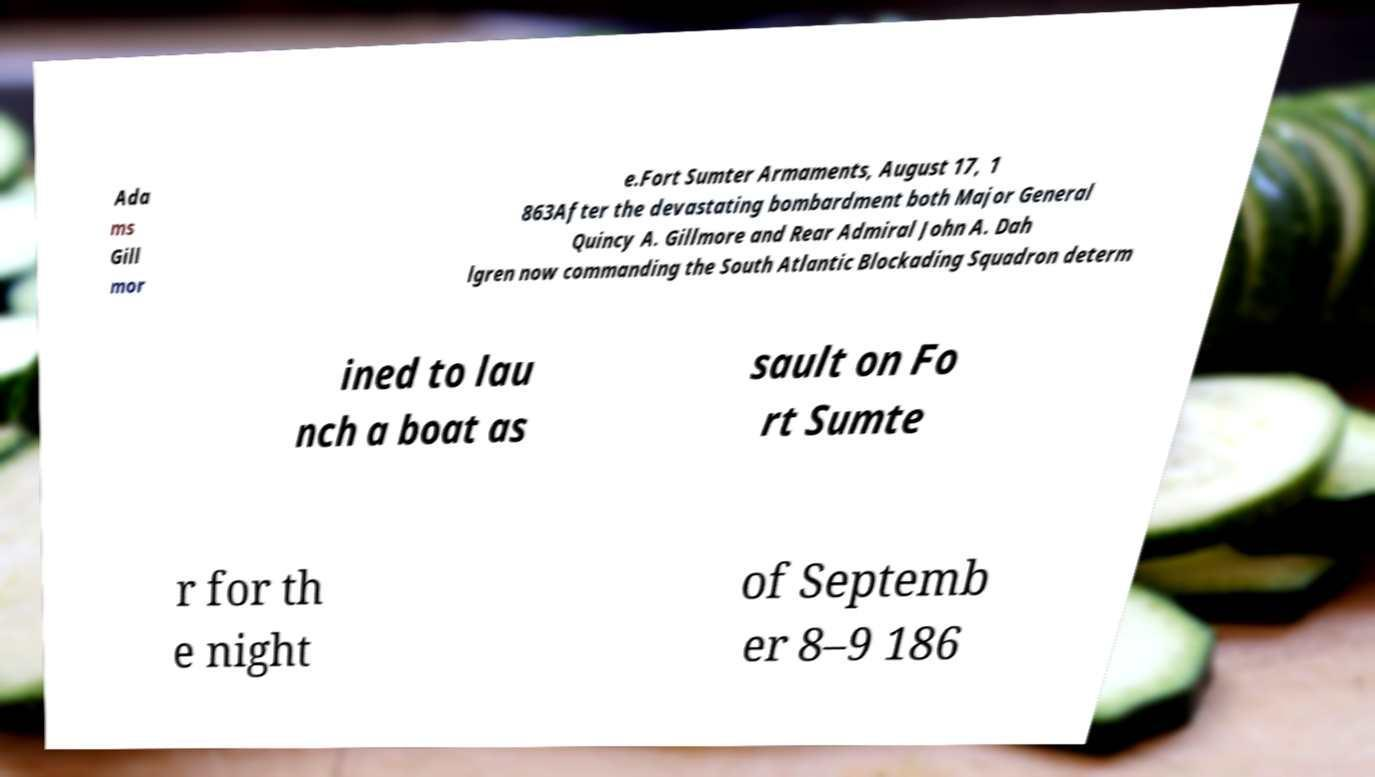There's text embedded in this image that I need extracted. Can you transcribe it verbatim? Ada ms Gill mor e.Fort Sumter Armaments, August 17, 1 863After the devastating bombardment both Major General Quincy A. Gillmore and Rear Admiral John A. Dah lgren now commanding the South Atlantic Blockading Squadron determ ined to lau nch a boat as sault on Fo rt Sumte r for th e night of Septemb er 8–9 186 